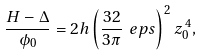Convert formula to latex. <formula><loc_0><loc_0><loc_500><loc_500>\frac { H - \Delta } { \phi _ { 0 } } = 2 h \left ( \frac { 3 2 } { 3 \pi } \ e p s \right ) ^ { 2 } z _ { 0 } ^ { \, 4 } ,</formula> 